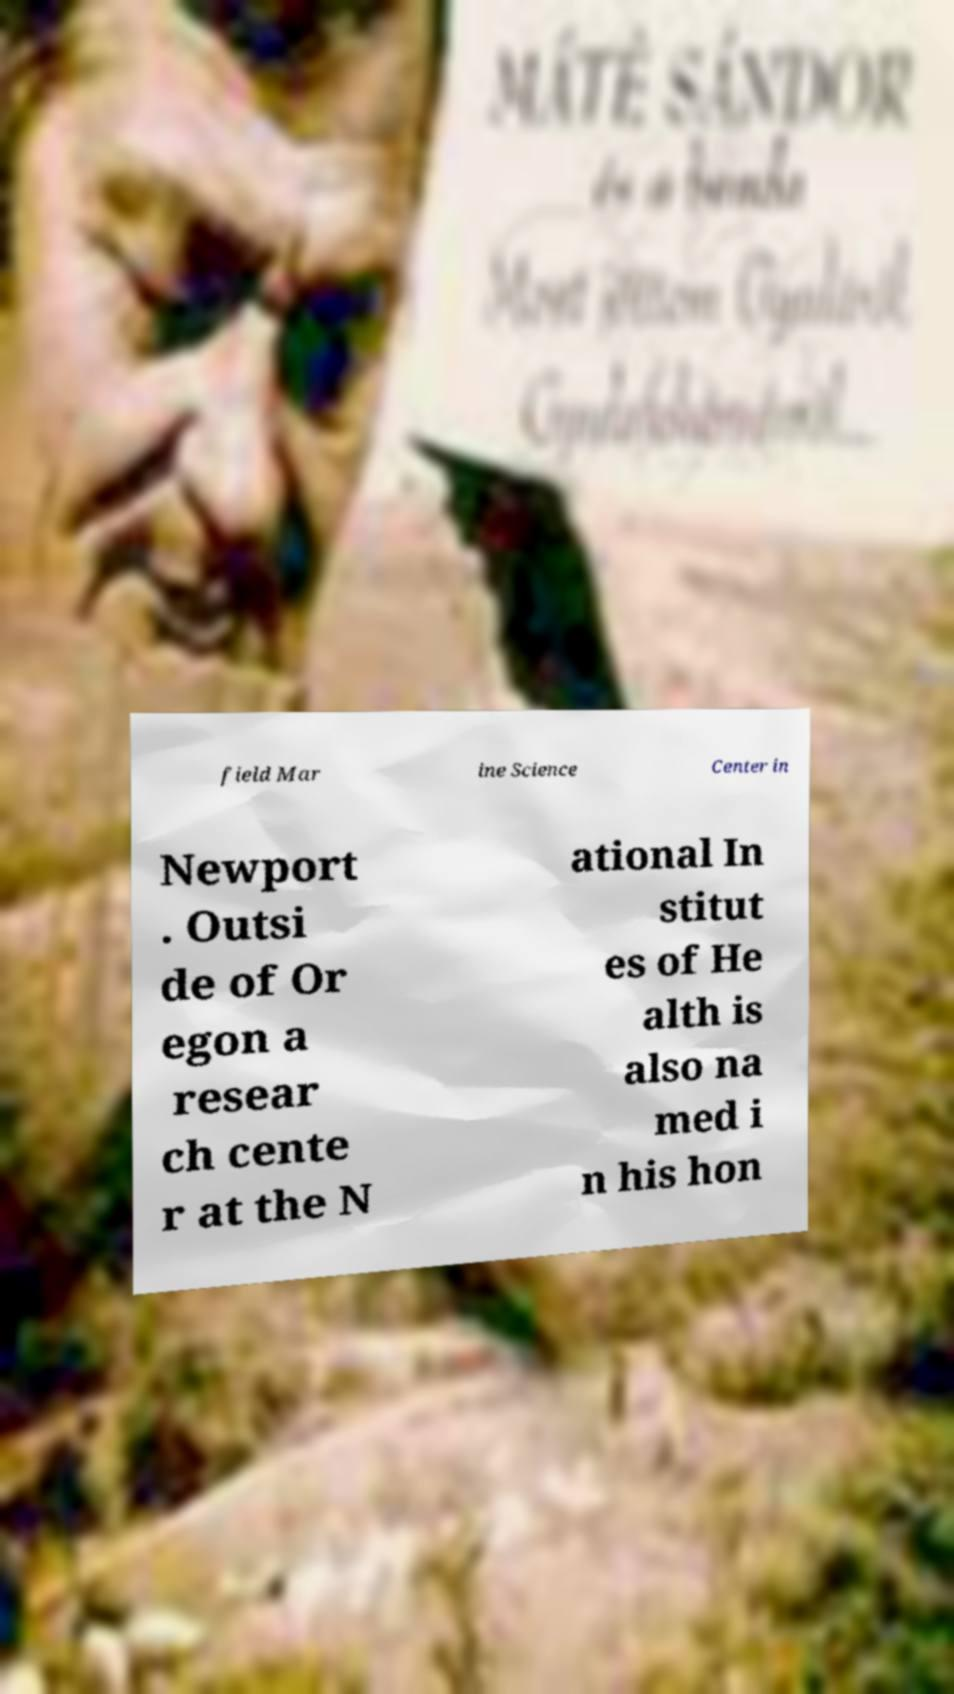I need the written content from this picture converted into text. Can you do that? field Mar ine Science Center in Newport . Outsi de of Or egon a resear ch cente r at the N ational In stitut es of He alth is also na med i n his hon 